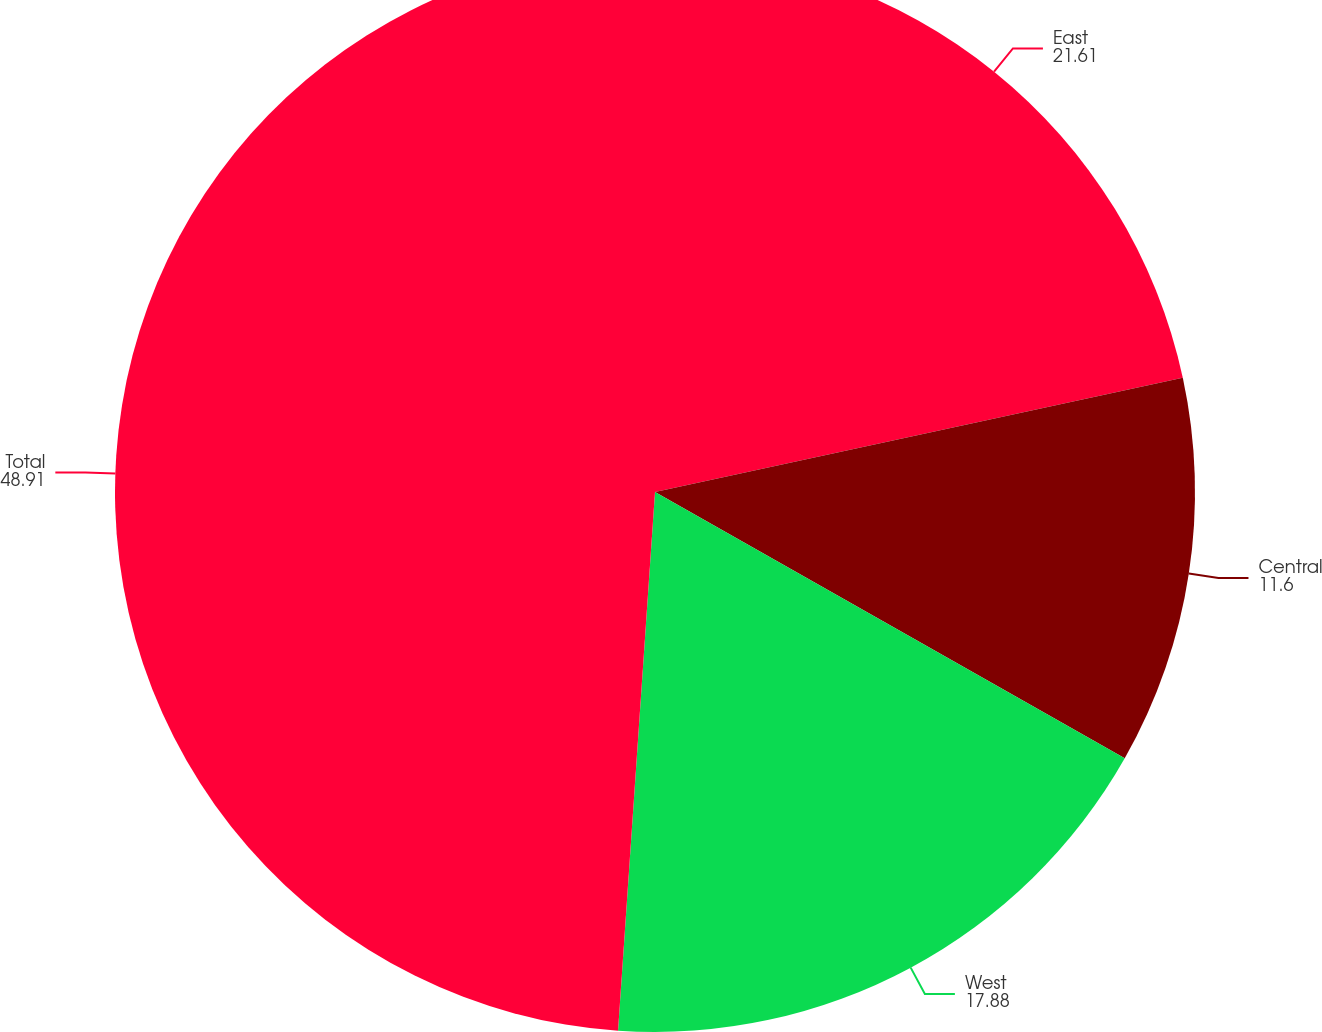Convert chart to OTSL. <chart><loc_0><loc_0><loc_500><loc_500><pie_chart><fcel>East<fcel>Central<fcel>West<fcel>Total<nl><fcel>21.61%<fcel>11.6%<fcel>17.88%<fcel>48.91%<nl></chart> 